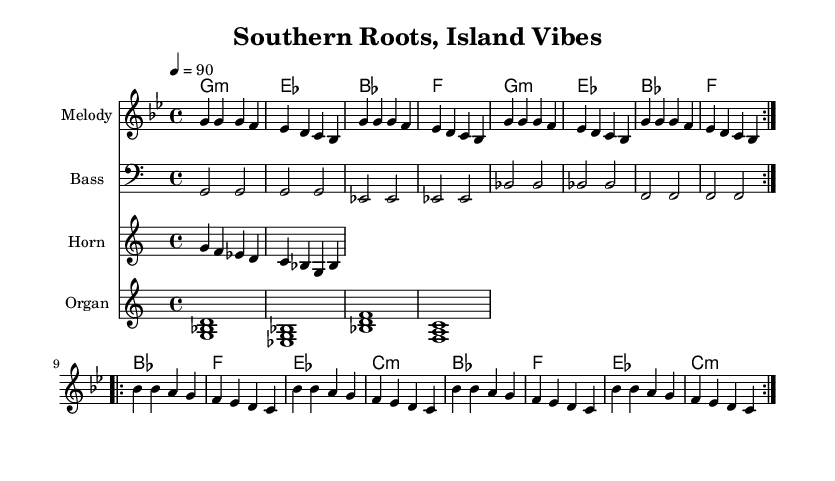What is the key signature of this music? The key signature is indicated at the beginning of the score, which shows one flat (B flat). This tells us the music is in G minor.
Answer: G minor What is the time signature of this music? The time signature is displayed at the beginning of the score and is 4/4, meaning there are four beats in each measure and a quarter note gets one beat.
Answer: 4/4 What is the tempo of this music? The tempo marking at the beginning indicates that the music should be played at 90 beats per minute, specified by the term "4 = 90".
Answer: 90 How many times is the melody repeated? The melody section shows a repeat structure with "volta 2" indicating that the melody should be played two times.
Answer: 2 What is the first chord in the harmony? Looking at the chord progression at the beginning of the score, the first chord listed is G minor, written as "g1:m".
Answer: G minor What type of instrumentation is used for the organ? The organ part is written in the treble clef with a specific chord voicing indicated at the beginning, typical for reggae-style music.
Answer: Treble clef What is the rhythmic feel of the bass line? The bass line has all notes played as quarter notes in a steady pattern matching reggae's characteristic laid-back groove, creating an offbeat rhythmic feel typical of the genre.
Answer: Laid-back 